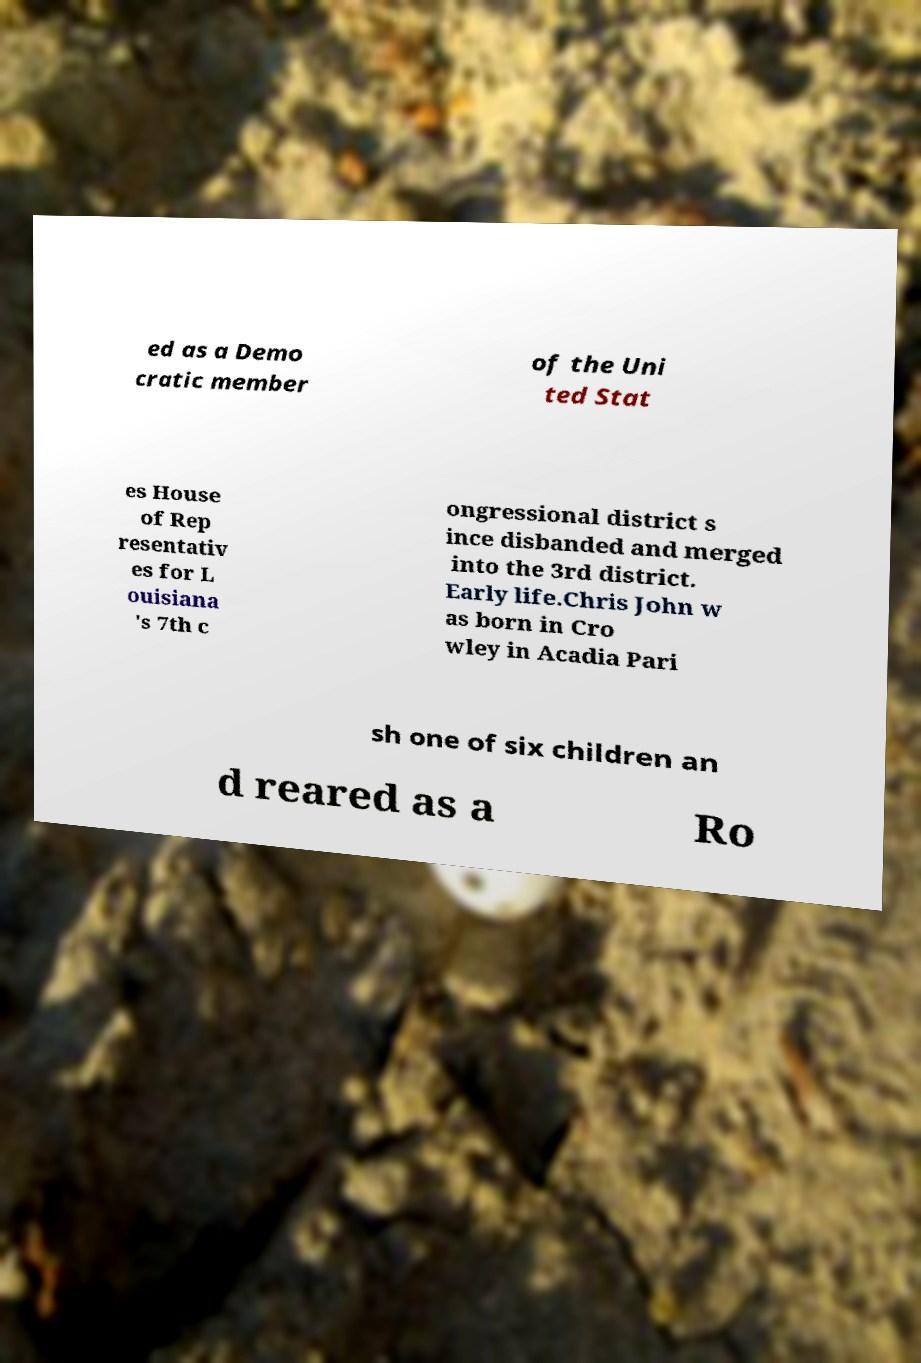What messages or text are displayed in this image? I need them in a readable, typed format. ed as a Demo cratic member of the Uni ted Stat es House of Rep resentativ es for L ouisiana 's 7th c ongressional district s ince disbanded and merged into the 3rd district. Early life.Chris John w as born in Cro wley in Acadia Pari sh one of six children an d reared as a Ro 